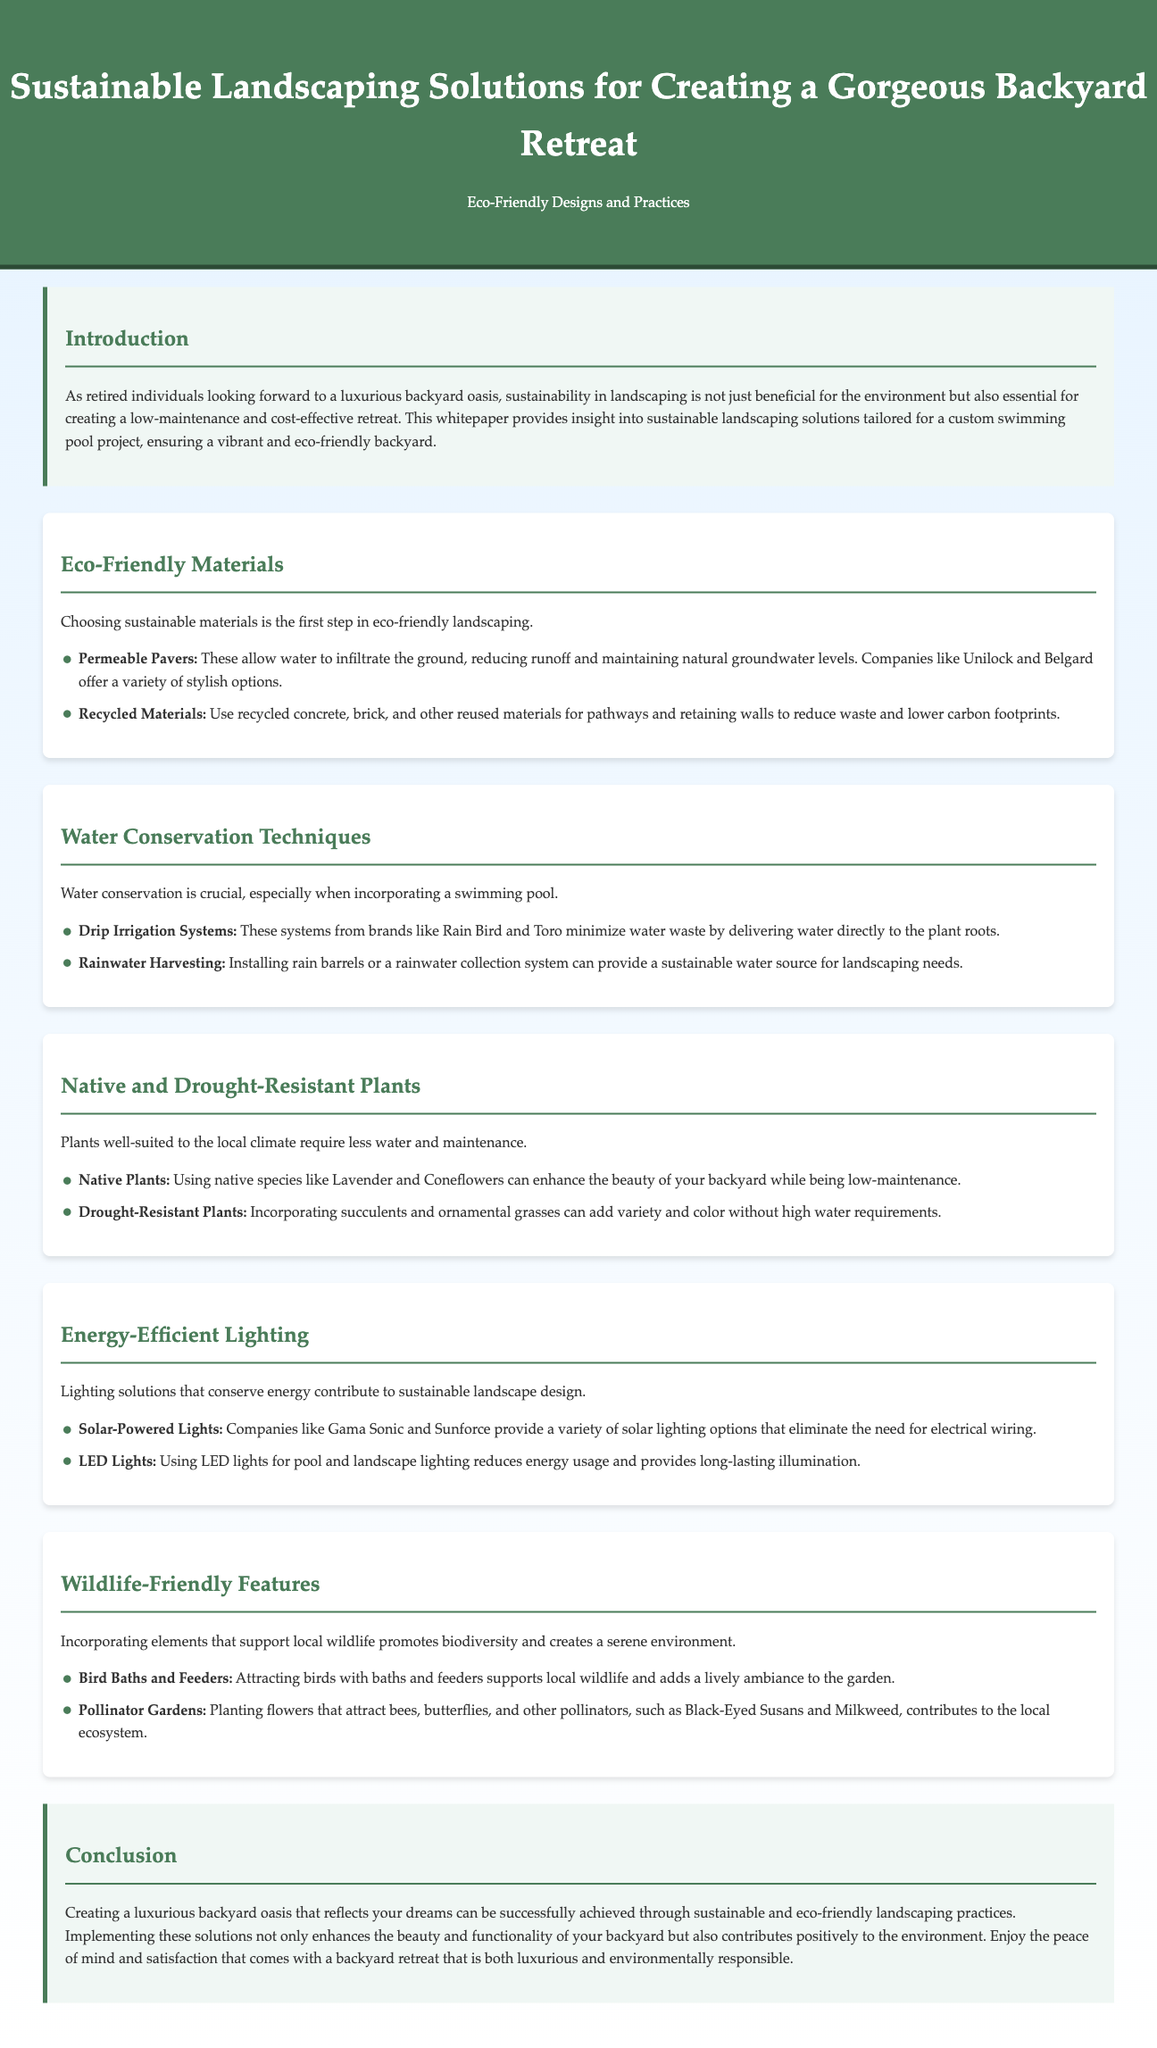What is the main purpose of this whitepaper? The whitepaper outlines sustainable landscaping solutions for creating a luxurious backyard retreat with eco-friendly designs and practices.
Answer: sustainable landscaping solutions What type of materials are highlighted as eco-friendly? The document mentions that choosing sustainable materials, such as permeable pavers and recycled materials, is the first step in eco-friendly landscaping.
Answer: permeable pavers, recycled materials What is suggested for water conservation? The whitepaper recommends drip irrigation systems and rainwater harvesting as essential techniques for conserving water when incorporating a swimming pool.
Answer: drip irrigation systems, rainwater harvesting Which plants are low-maintenance and drought-resistant? The text points out that using native species and drought-resistant plants, such as succulents and ornamental grasses, can enhance beauty while being easy to maintain.
Answer: native species, drought-resistant plants What type of lighting is recommended for energy efficiency? The document indicates that solar-powered lights and LED lights are excellent choices for energy-efficient lighting in landscaping.
Answer: solar-powered lights, LED lights Which wildlife-friendly features are suggested? The whitepaper encourages adding bird baths and pollinator gardens to support local wildlife and promote biodiversity.
Answer: bird baths, pollinator gardens How does the introduction describe the audience for this whitepaper? The introduction refers specifically to retired individuals who are looking forward to a luxurious backyard oasis through sustainable practices.
Answer: retired individuals What is emphasized in the conclusion of the whitepaper? The conclusion emphasizes that a luxurious backyard oasis can be achieved through sustainable and eco-friendly landscaping practices, enhancing both beauty and environmental contribution.
Answer: sustainable and eco-friendly landscaping practices 